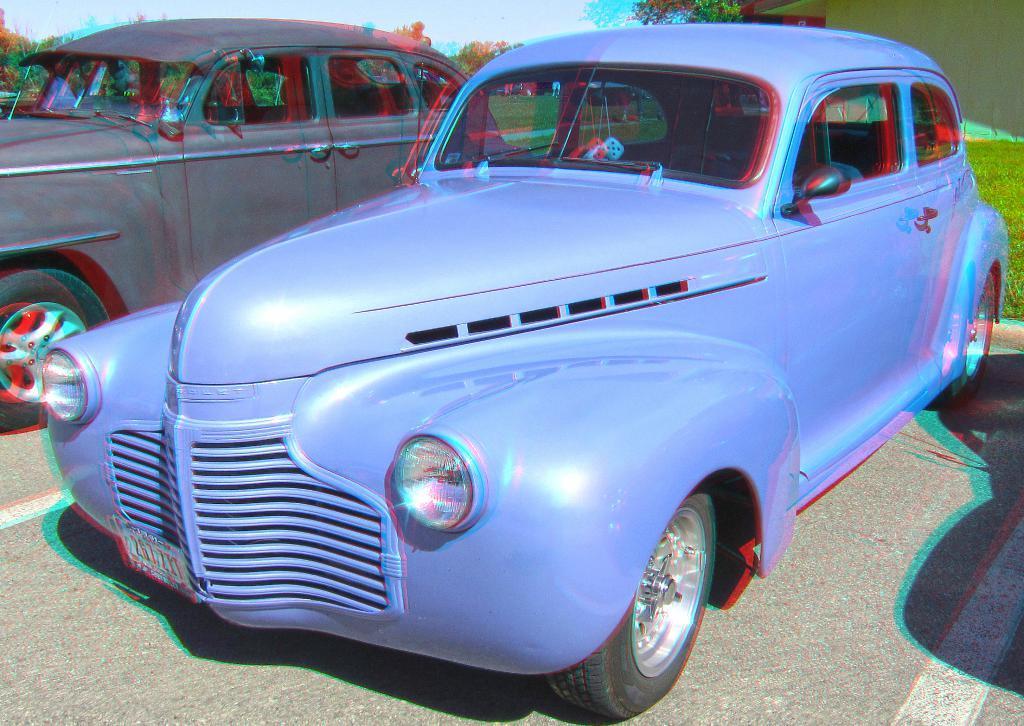Please provide a concise description of this image. In the picture we can see two vintage cars which are parked on the path, one car is blue in color and one car is gray in color and behind it we can see grass surface, trees and sky. 